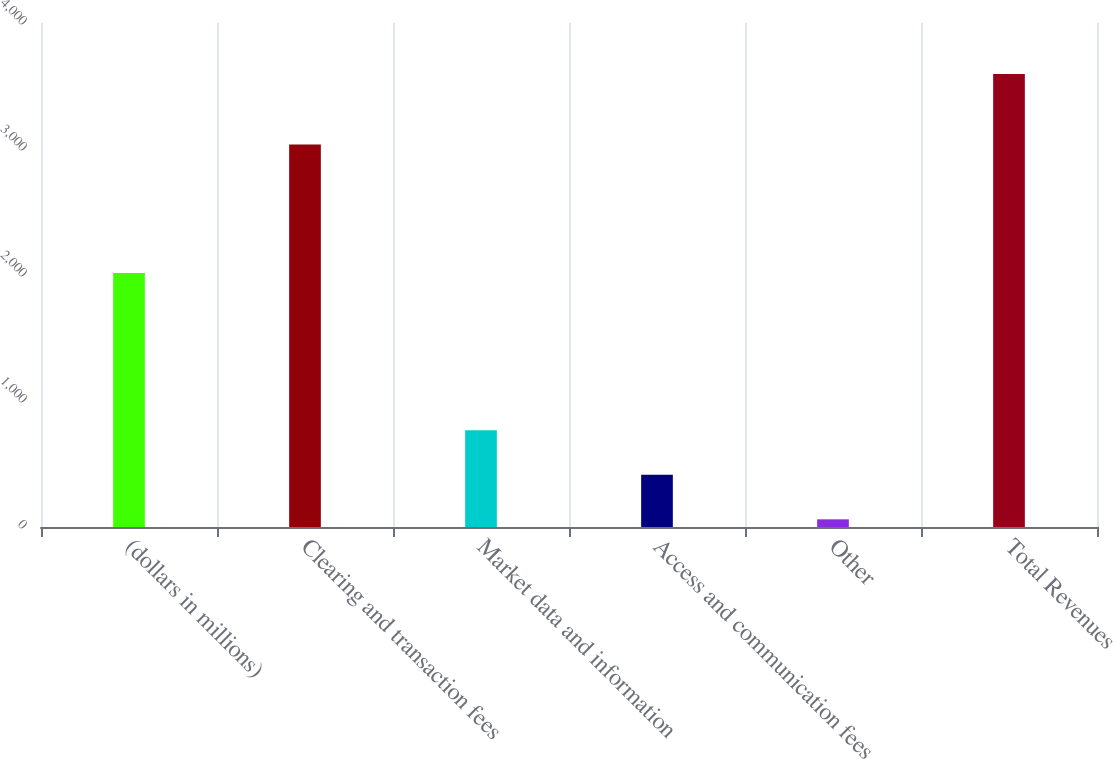Convert chart. <chart><loc_0><loc_0><loc_500><loc_500><bar_chart><fcel>(dollars in millions)<fcel>Clearing and transaction fees<fcel>Market data and information<fcel>Access and communication fees<fcel>Other<fcel>Total Revenues<nl><fcel>2016<fcel>3036.4<fcel>767.76<fcel>414.33<fcel>60.9<fcel>3595.2<nl></chart> 